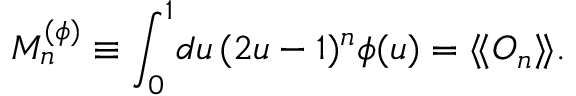Convert formula to latex. <formula><loc_0><loc_0><loc_500><loc_500>M _ { n } ^ { ( \phi ) } \equiv \int _ { 0 } ^ { 1 } \, d u \, ( 2 u - 1 ) ^ { n } \phi ( u ) = \langle \, \langle O _ { n } \rangle \, \rangle .</formula> 